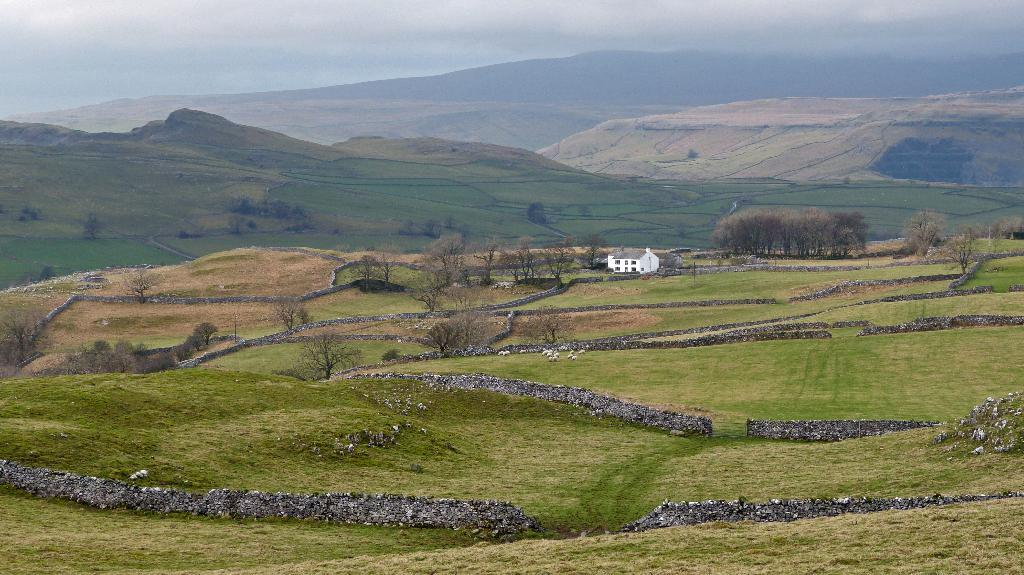What is the main structure in the center of the image? There is a house in the center of the image. What type of vegetation is present at the bottom of the image? There is grass on the surface at the bottom of the image. What can be seen in the background of the image? There are trees, mountains, and the sky visible in the background of the image. What type of straw is used to make the coat in the image? There is no straw or coat present in the image. How does the cork affect the appearance of the mountains in the image? There is no cork present in the image, so it cannot affect the appearance of the mountains. 